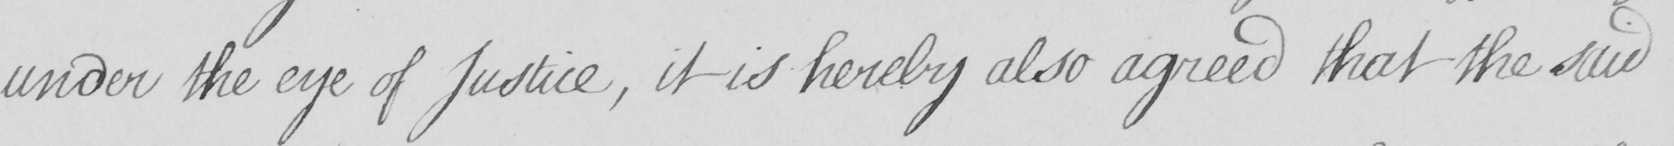What is written in this line of handwriting? under the eye of Justice , it is hereby also agreed that the said 